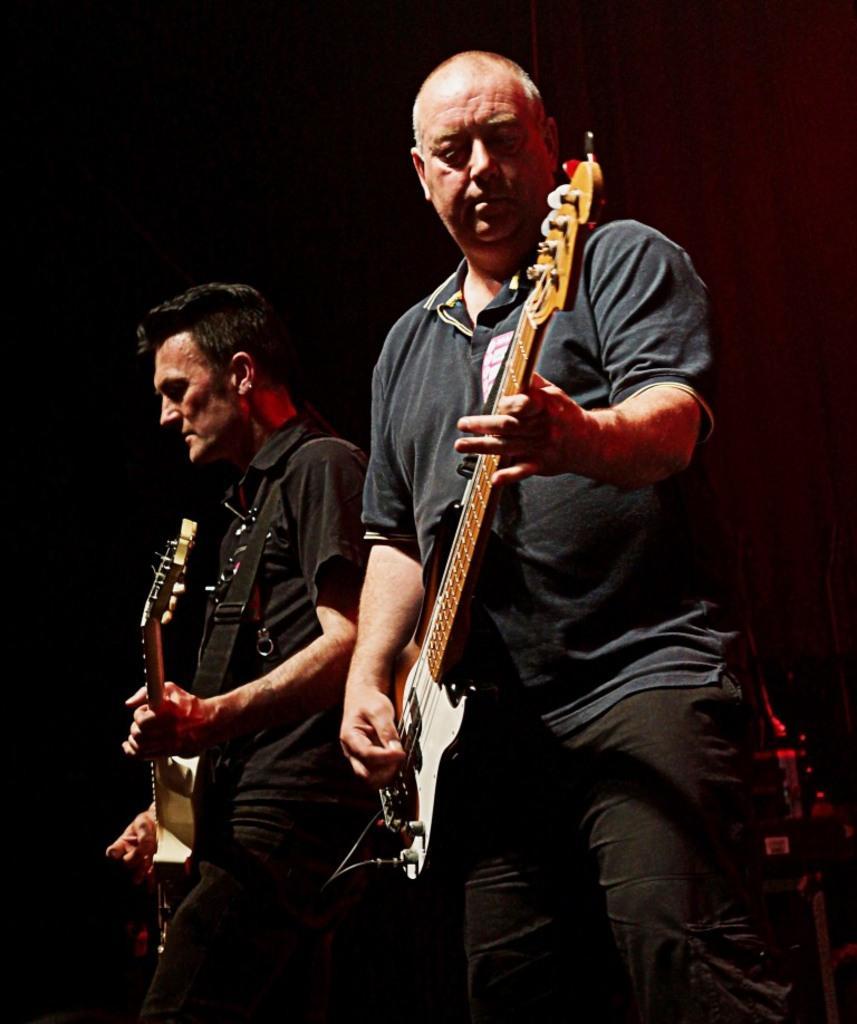How would you summarize this image in a sentence or two? In the center of the image, we can see people playing guitar. 